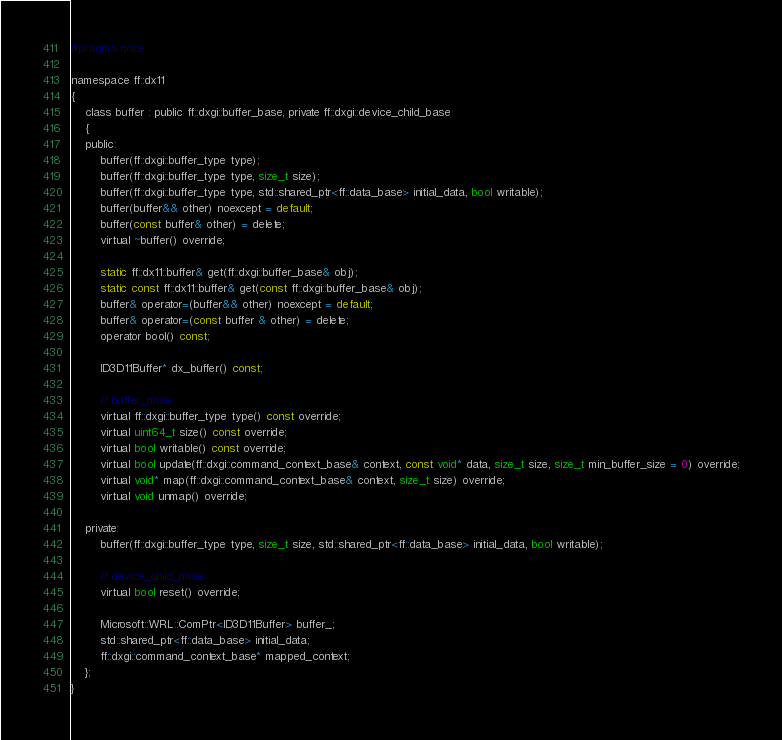<code> <loc_0><loc_0><loc_500><loc_500><_C_>#pragma once

namespace ff::dx11
{
    class buffer : public ff::dxgi::buffer_base, private ff::dxgi::device_child_base
    {
    public:
        buffer(ff::dxgi::buffer_type type);
        buffer(ff::dxgi::buffer_type type, size_t size);
        buffer(ff::dxgi::buffer_type type, std::shared_ptr<ff::data_base> initial_data, bool writable);
        buffer(buffer&& other) noexcept = default;
        buffer(const buffer& other) = delete;
        virtual ~buffer() override;

        static ff::dx11::buffer& get(ff::dxgi::buffer_base& obj);
        static const ff::dx11::buffer& get(const ff::dxgi::buffer_base& obj);
        buffer& operator=(buffer&& other) noexcept = default;
        buffer& operator=(const buffer & other) = delete;
        operator bool() const;

        ID3D11Buffer* dx_buffer() const;

        // buffer_base
        virtual ff::dxgi::buffer_type type() const override;
        virtual uint64_t size() const override;
        virtual bool writable() const override;
        virtual bool update(ff::dxgi::command_context_base& context, const void* data, size_t size, size_t min_buffer_size = 0) override;
        virtual void* map(ff::dxgi::command_context_base& context, size_t size) override;
        virtual void unmap() override;

    private:
        buffer(ff::dxgi::buffer_type type, size_t size, std::shared_ptr<ff::data_base> initial_data, bool writable);

        // device_child_base
        virtual bool reset() override;

        Microsoft::WRL::ComPtr<ID3D11Buffer> buffer_;
        std::shared_ptr<ff::data_base> initial_data;
        ff::dxgi::command_context_base* mapped_context;
    };
}
</code> 